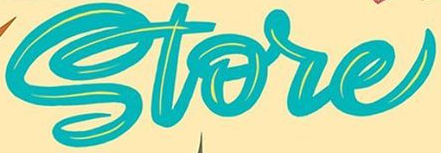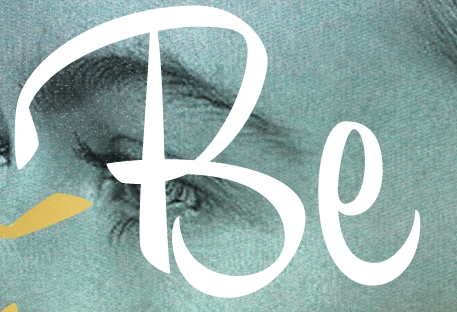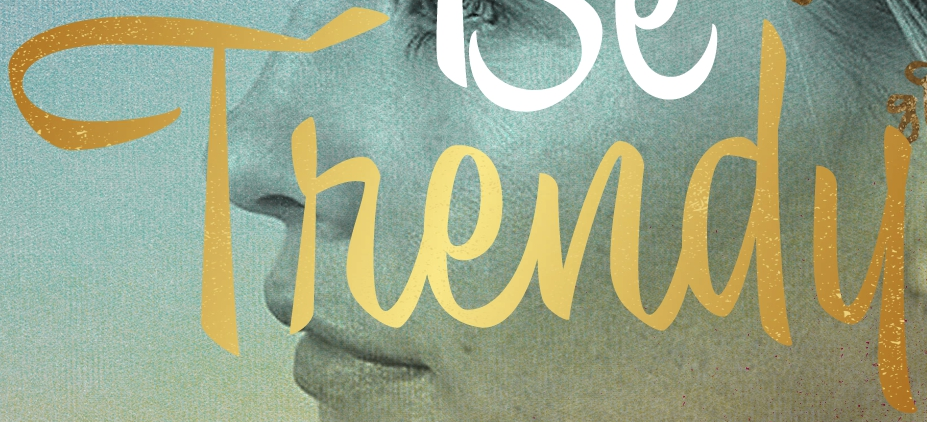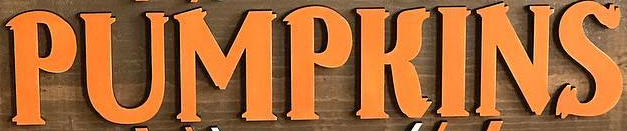What words can you see in these images in sequence, separated by a semicolon? Store; Be; Thendu; PUMPKINS 